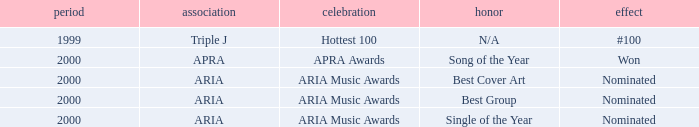What were the results before the year 2000? #100. 